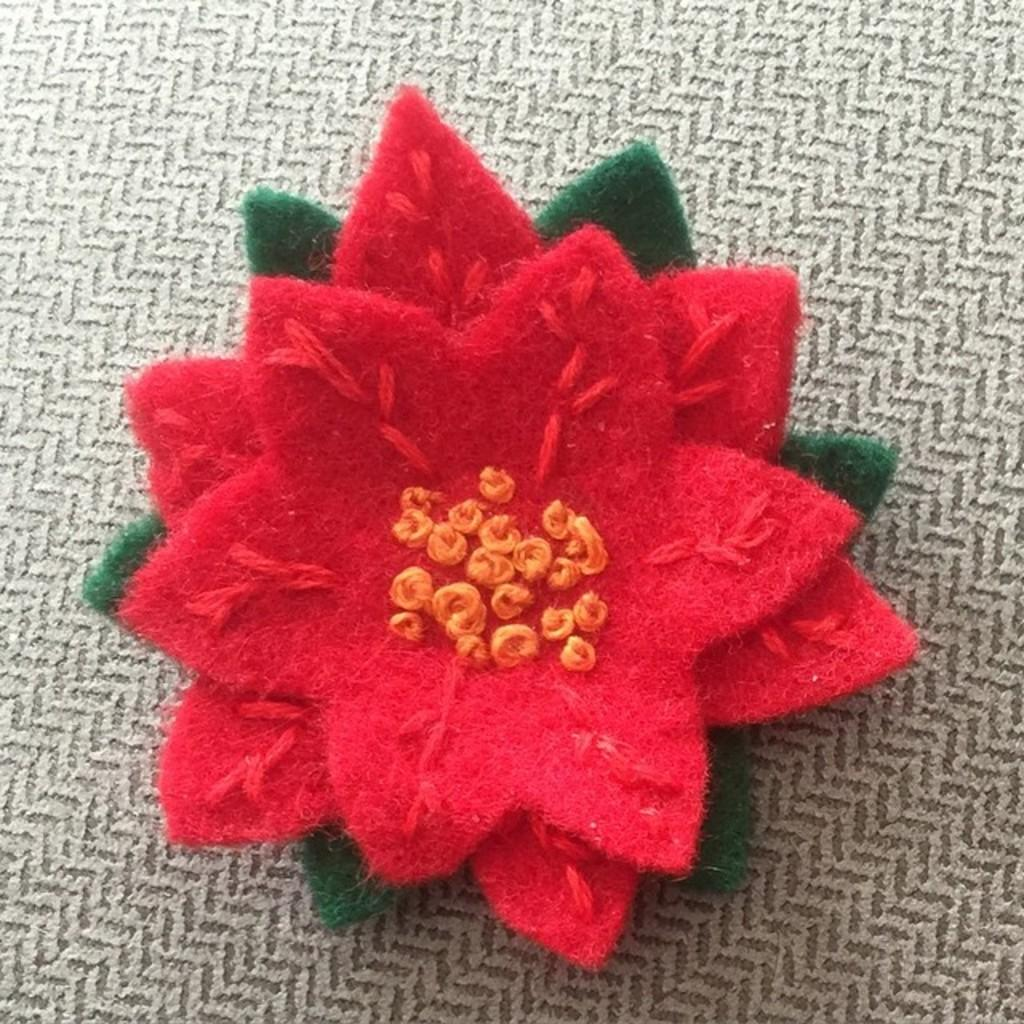What type of object is made of woolen material in the image? There is a made-by-woolen object in the image. Where is the woolen object placed? The made-by-woolen object is placed on a carpet. What is the carpet resting on in the image? The carpet is on the floor. What type of suit is the bird wearing in the image? There is no bird present in the image, and therefore no bird wearing a suit. 